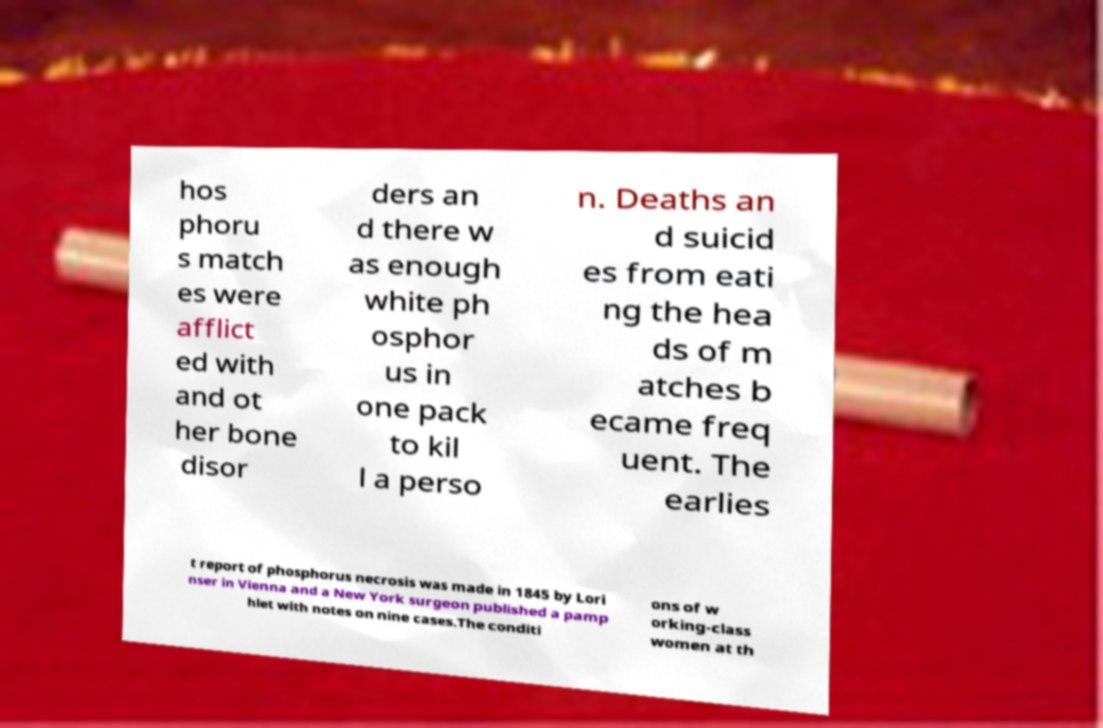There's text embedded in this image that I need extracted. Can you transcribe it verbatim? hos phoru s match es were afflict ed with and ot her bone disor ders an d there w as enough white ph osphor us in one pack to kil l a perso n. Deaths an d suicid es from eati ng the hea ds of m atches b ecame freq uent. The earlies t report of phosphorus necrosis was made in 1845 by Lori nser in Vienna and a New York surgeon published a pamp hlet with notes on nine cases.The conditi ons of w orking-class women at th 